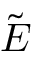Convert formula to latex. <formula><loc_0><loc_0><loc_500><loc_500>\tilde { E }</formula> 